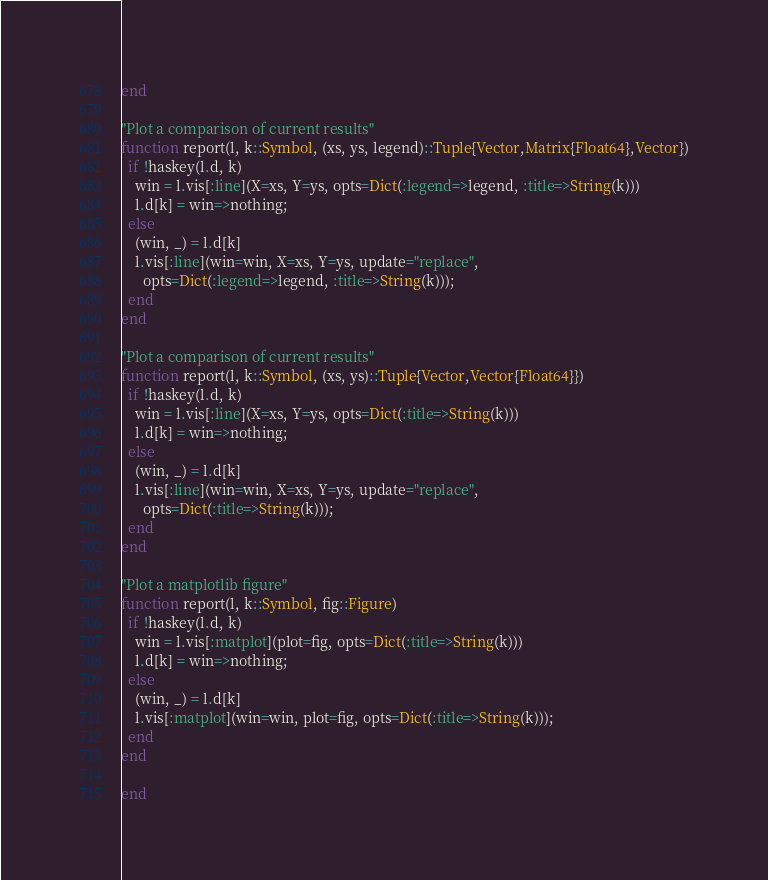<code> <loc_0><loc_0><loc_500><loc_500><_Julia_>end

"Plot a comparison of current results"
function report(l, k::Symbol, (xs, ys, legend)::Tuple{Vector,Matrix{Float64},Vector})
  if !haskey(l.d, k)
    win = l.vis[:line](X=xs, Y=ys, opts=Dict(:legend=>legend, :title=>String(k)))
    l.d[k] = win=>nothing;
  else
    (win, _) = l.d[k]
    l.vis[:line](win=win, X=xs, Y=ys, update="replace",
      opts=Dict(:legend=>legend, :title=>String(k)));
  end
end

"Plot a comparison of current results"
function report(l, k::Symbol, (xs, ys)::Tuple{Vector,Vector{Float64}})
  if !haskey(l.d, k)
    win = l.vis[:line](X=xs, Y=ys, opts=Dict(:title=>String(k)))
    l.d[k] = win=>nothing;
  else
    (win, _) = l.d[k]
    l.vis[:line](win=win, X=xs, Y=ys, update="replace",
      opts=Dict(:title=>String(k)));
  end
end

"Plot a matplotlib figure"
function report(l, k::Symbol, fig::Figure)
  if !haskey(l.d, k)
    win = l.vis[:matplot](plot=fig, opts=Dict(:title=>String(k)))
    l.d[k] = win=>nothing;
  else
    (win, _) = l.d[k]
    l.vis[:matplot](win=win, plot=fig, opts=Dict(:title=>String(k)));
  end
end

end
</code> 